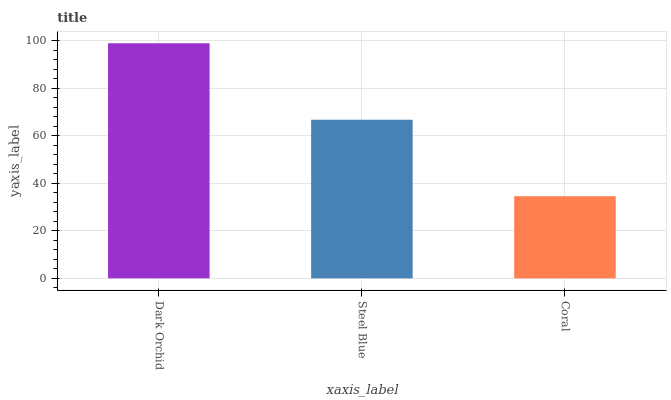Is Steel Blue the minimum?
Answer yes or no. No. Is Steel Blue the maximum?
Answer yes or no. No. Is Dark Orchid greater than Steel Blue?
Answer yes or no. Yes. Is Steel Blue less than Dark Orchid?
Answer yes or no. Yes. Is Steel Blue greater than Dark Orchid?
Answer yes or no. No. Is Dark Orchid less than Steel Blue?
Answer yes or no. No. Is Steel Blue the high median?
Answer yes or no. Yes. Is Steel Blue the low median?
Answer yes or no. Yes. Is Dark Orchid the high median?
Answer yes or no. No. Is Coral the low median?
Answer yes or no. No. 